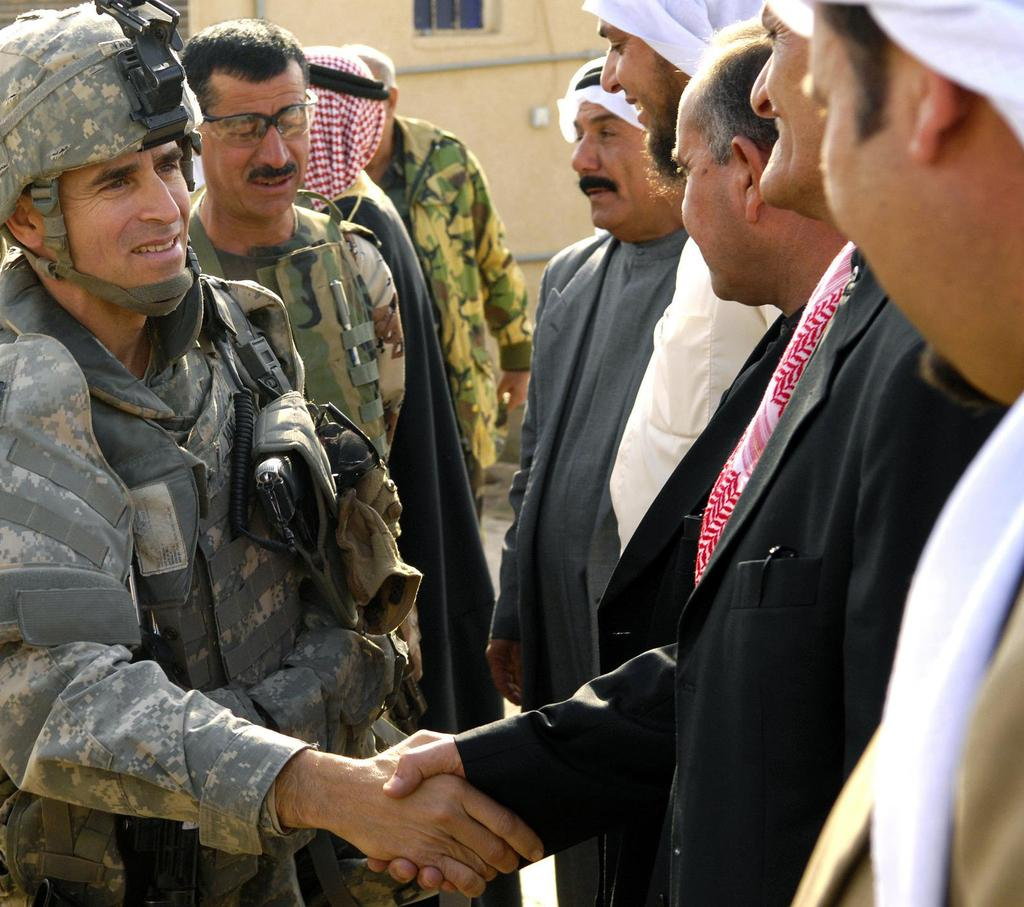What are the people in the image doing? Two men are shaking hands in the image. Can you describe the background of the image? There is a wall and a window in the background of the image. How many people are present in the image? There are people standing in the image, but the exact number is not specified. Can you see any ants crawling on the men in the image? There are no ants visible in the image. What type of pickle is being used as a prop in the handshake? There is no pickle present in the image. 